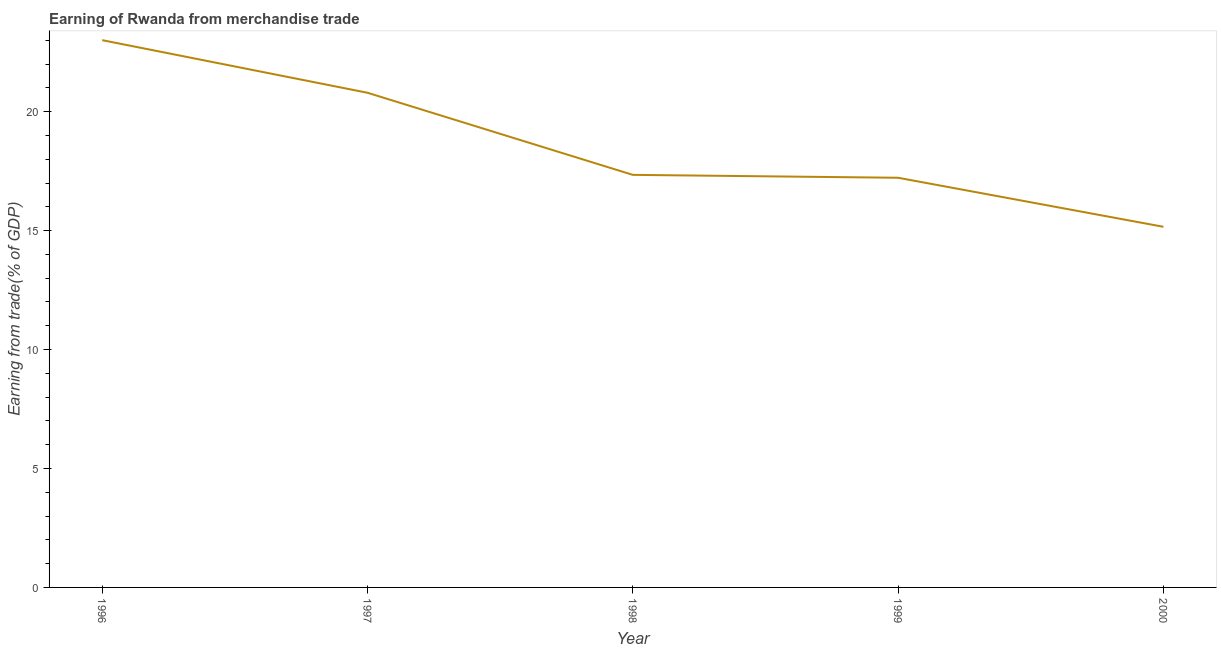What is the earning from merchandise trade in 2000?
Offer a terse response. 15.16. Across all years, what is the maximum earning from merchandise trade?
Offer a very short reply. 23. Across all years, what is the minimum earning from merchandise trade?
Your response must be concise. 15.16. What is the sum of the earning from merchandise trade?
Offer a terse response. 93.52. What is the difference between the earning from merchandise trade in 1996 and 1998?
Ensure brevity in your answer.  5.66. What is the average earning from merchandise trade per year?
Give a very brief answer. 18.7. What is the median earning from merchandise trade?
Keep it short and to the point. 17.34. What is the ratio of the earning from merchandise trade in 1998 to that in 2000?
Your answer should be very brief. 1.14. Is the difference between the earning from merchandise trade in 1996 and 1999 greater than the difference between any two years?
Your response must be concise. No. What is the difference between the highest and the second highest earning from merchandise trade?
Your answer should be very brief. 2.21. What is the difference between the highest and the lowest earning from merchandise trade?
Make the answer very short. 7.85. In how many years, is the earning from merchandise trade greater than the average earning from merchandise trade taken over all years?
Offer a very short reply. 2. How many lines are there?
Your response must be concise. 1. How many years are there in the graph?
Your response must be concise. 5. What is the difference between two consecutive major ticks on the Y-axis?
Ensure brevity in your answer.  5. Are the values on the major ticks of Y-axis written in scientific E-notation?
Your response must be concise. No. What is the title of the graph?
Provide a succinct answer. Earning of Rwanda from merchandise trade. What is the label or title of the X-axis?
Offer a terse response. Year. What is the label or title of the Y-axis?
Offer a terse response. Earning from trade(% of GDP). What is the Earning from trade(% of GDP) in 1996?
Provide a succinct answer. 23. What is the Earning from trade(% of GDP) of 1997?
Offer a very short reply. 20.79. What is the Earning from trade(% of GDP) of 1998?
Your answer should be very brief. 17.34. What is the Earning from trade(% of GDP) in 1999?
Offer a very short reply. 17.22. What is the Earning from trade(% of GDP) of 2000?
Ensure brevity in your answer.  15.16. What is the difference between the Earning from trade(% of GDP) in 1996 and 1997?
Keep it short and to the point. 2.21. What is the difference between the Earning from trade(% of GDP) in 1996 and 1998?
Give a very brief answer. 5.66. What is the difference between the Earning from trade(% of GDP) in 1996 and 1999?
Keep it short and to the point. 5.78. What is the difference between the Earning from trade(% of GDP) in 1996 and 2000?
Ensure brevity in your answer.  7.85. What is the difference between the Earning from trade(% of GDP) in 1997 and 1998?
Provide a short and direct response. 3.45. What is the difference between the Earning from trade(% of GDP) in 1997 and 1999?
Offer a terse response. 3.57. What is the difference between the Earning from trade(% of GDP) in 1997 and 2000?
Your answer should be compact. 5.63. What is the difference between the Earning from trade(% of GDP) in 1998 and 1999?
Provide a succinct answer. 0.12. What is the difference between the Earning from trade(% of GDP) in 1998 and 2000?
Keep it short and to the point. 2.18. What is the difference between the Earning from trade(% of GDP) in 1999 and 2000?
Make the answer very short. 2.06. What is the ratio of the Earning from trade(% of GDP) in 1996 to that in 1997?
Provide a short and direct response. 1.11. What is the ratio of the Earning from trade(% of GDP) in 1996 to that in 1998?
Provide a succinct answer. 1.33. What is the ratio of the Earning from trade(% of GDP) in 1996 to that in 1999?
Offer a very short reply. 1.34. What is the ratio of the Earning from trade(% of GDP) in 1996 to that in 2000?
Your answer should be very brief. 1.52. What is the ratio of the Earning from trade(% of GDP) in 1997 to that in 1998?
Ensure brevity in your answer.  1.2. What is the ratio of the Earning from trade(% of GDP) in 1997 to that in 1999?
Your response must be concise. 1.21. What is the ratio of the Earning from trade(% of GDP) in 1997 to that in 2000?
Make the answer very short. 1.37. What is the ratio of the Earning from trade(% of GDP) in 1998 to that in 2000?
Your answer should be compact. 1.14. What is the ratio of the Earning from trade(% of GDP) in 1999 to that in 2000?
Give a very brief answer. 1.14. 